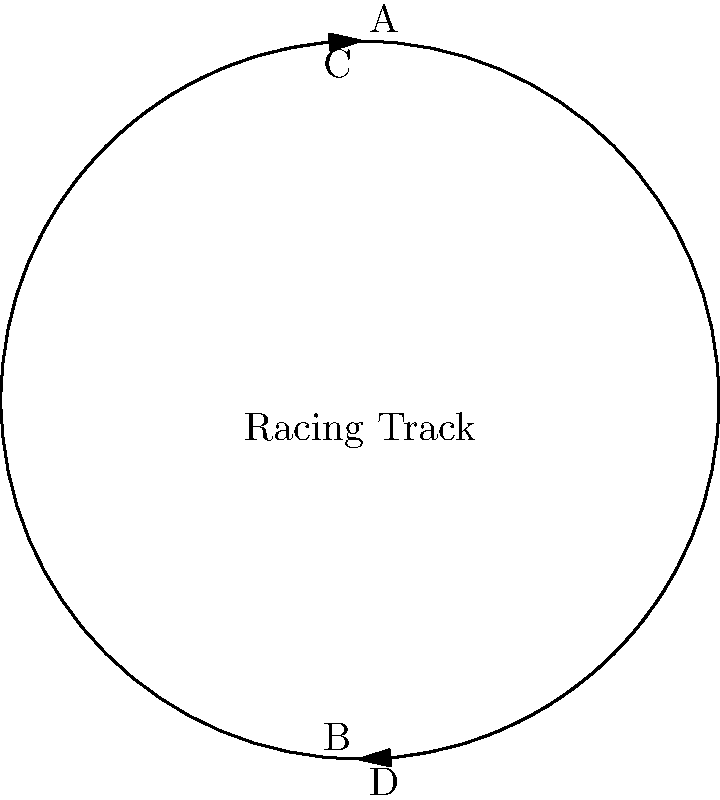In a hyperbolic plane, a classic racing track is designed as shown in the diagram. If the track follows geodesics (shortest paths) in this non-Euclidean space, how would the shape of the track differ from a circular track in Euclidean space, and what implications would this have for racing strategy? To understand the implications of a racing track in a hyperbolic plane, we need to consider the following steps:

1. Geodesics in hyperbolic space:
   In a hyperbolic plane, geodesics (shortest paths) are not straight lines as in Euclidean space. They appear curved when represented in Euclidean space.

2. Track shape:
   The circular track shown in the Euclidean representation would actually be a more complex shape in hyperbolic space. The "straight" sections between curves would appear to bow outwards.

3. Curvature of space-time:
   In hyperbolic geometry, the curvature of space is constant and negative. This means that parallel lines diverge and the sum of angles in a triangle is less than 180°.

4. Effect on racing lines:
   The optimal racing line would not be a smooth curve as in Euclidean space. Drivers would need to account for the bowing effect of the "straight" sections.

5. Distance perception:
   Distances in hyperbolic space appear greater than they actually are. This would affect a driver's judgment of braking points and overtaking opportunities.

6. Acceleration and deceleration:
   The non-uniform nature of hyperbolic space would cause variations in apparent acceleration and deceleration around the track, even at constant speed.

7. Car design implications:
   Engineers would need to design cars to handle the unique forces experienced in hyperbolic space, potentially leading to very different aerodynamics and suspension systems.

8. Racing strategy:
   Drivers would need to develop new strategies to account for the non-intuitive nature of motion in hyperbolic space. Traditional racing lines and techniques would not be optimal.
Answer: The track would appear to bow outwards between curves, affecting racing lines, distance perception, and overall strategy. 